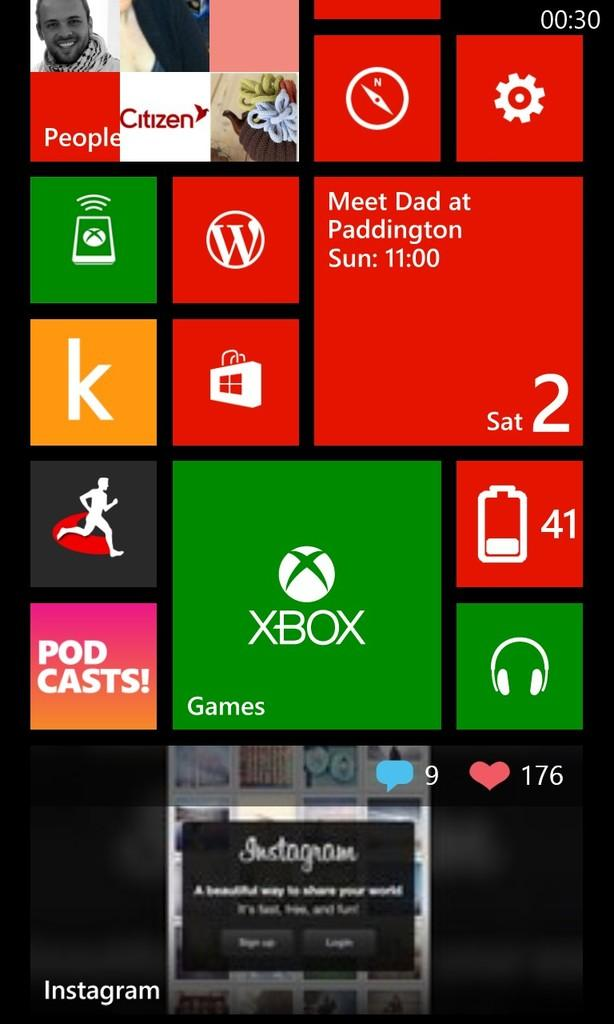<image>
Provide a brief description of the given image. a screen with many features of technology on it like XBOX, and others. 